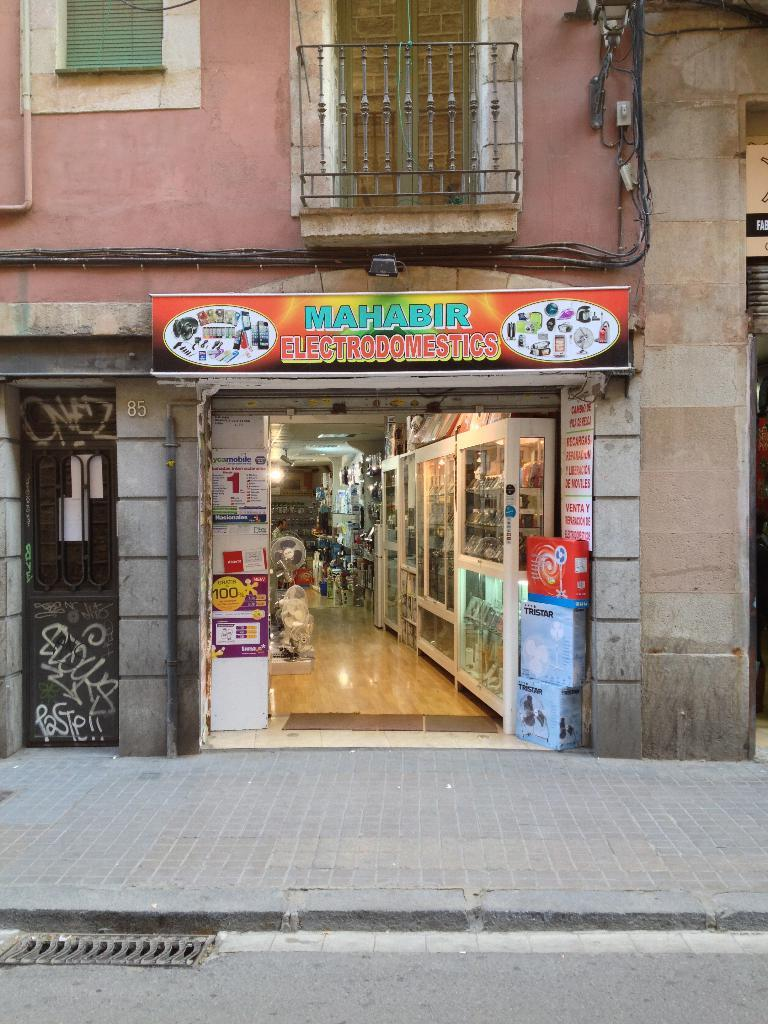<image>
Describe the image concisely. The banner over the entrance indicates the name of the business is Mahabir Electronics. 